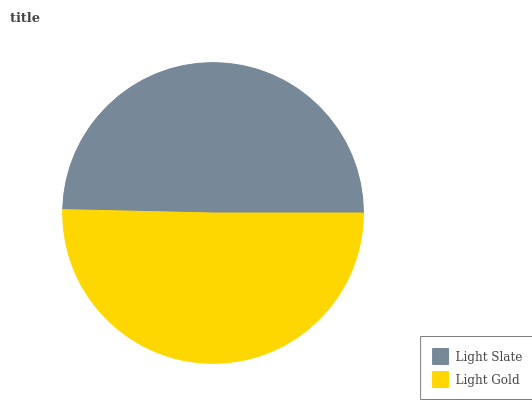Is Light Slate the minimum?
Answer yes or no. Yes. Is Light Gold the maximum?
Answer yes or no. Yes. Is Light Gold the minimum?
Answer yes or no. No. Is Light Gold greater than Light Slate?
Answer yes or no. Yes. Is Light Slate less than Light Gold?
Answer yes or no. Yes. Is Light Slate greater than Light Gold?
Answer yes or no. No. Is Light Gold less than Light Slate?
Answer yes or no. No. Is Light Gold the high median?
Answer yes or no. Yes. Is Light Slate the low median?
Answer yes or no. Yes. Is Light Slate the high median?
Answer yes or no. No. Is Light Gold the low median?
Answer yes or no. No. 